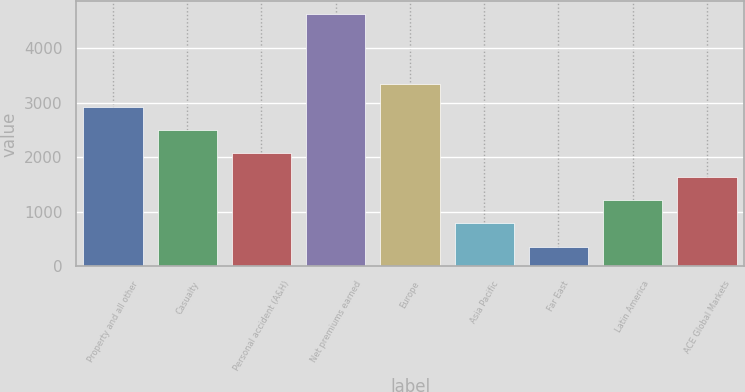Convert chart to OTSL. <chart><loc_0><loc_0><loc_500><loc_500><bar_chart><fcel>Property and all other<fcel>Casualty<fcel>Personal accident (A&H)<fcel>Net premiums earned<fcel>Europe<fcel>Asia Pacific<fcel>Far East<fcel>Latin America<fcel>ACE Global Markets<nl><fcel>2919.8<fcel>2494<fcel>2068.2<fcel>4623<fcel>3345.6<fcel>790.8<fcel>365<fcel>1216.6<fcel>1642.4<nl></chart> 